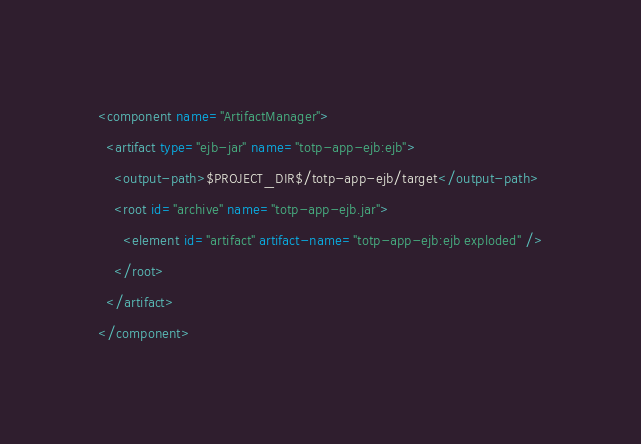<code> <loc_0><loc_0><loc_500><loc_500><_XML_><component name="ArtifactManager">
  <artifact type="ejb-jar" name="totp-app-ejb:ejb">
    <output-path>$PROJECT_DIR$/totp-app-ejb/target</output-path>
    <root id="archive" name="totp-app-ejb.jar">
      <element id="artifact" artifact-name="totp-app-ejb:ejb exploded" />
    </root>
  </artifact>
</component></code> 